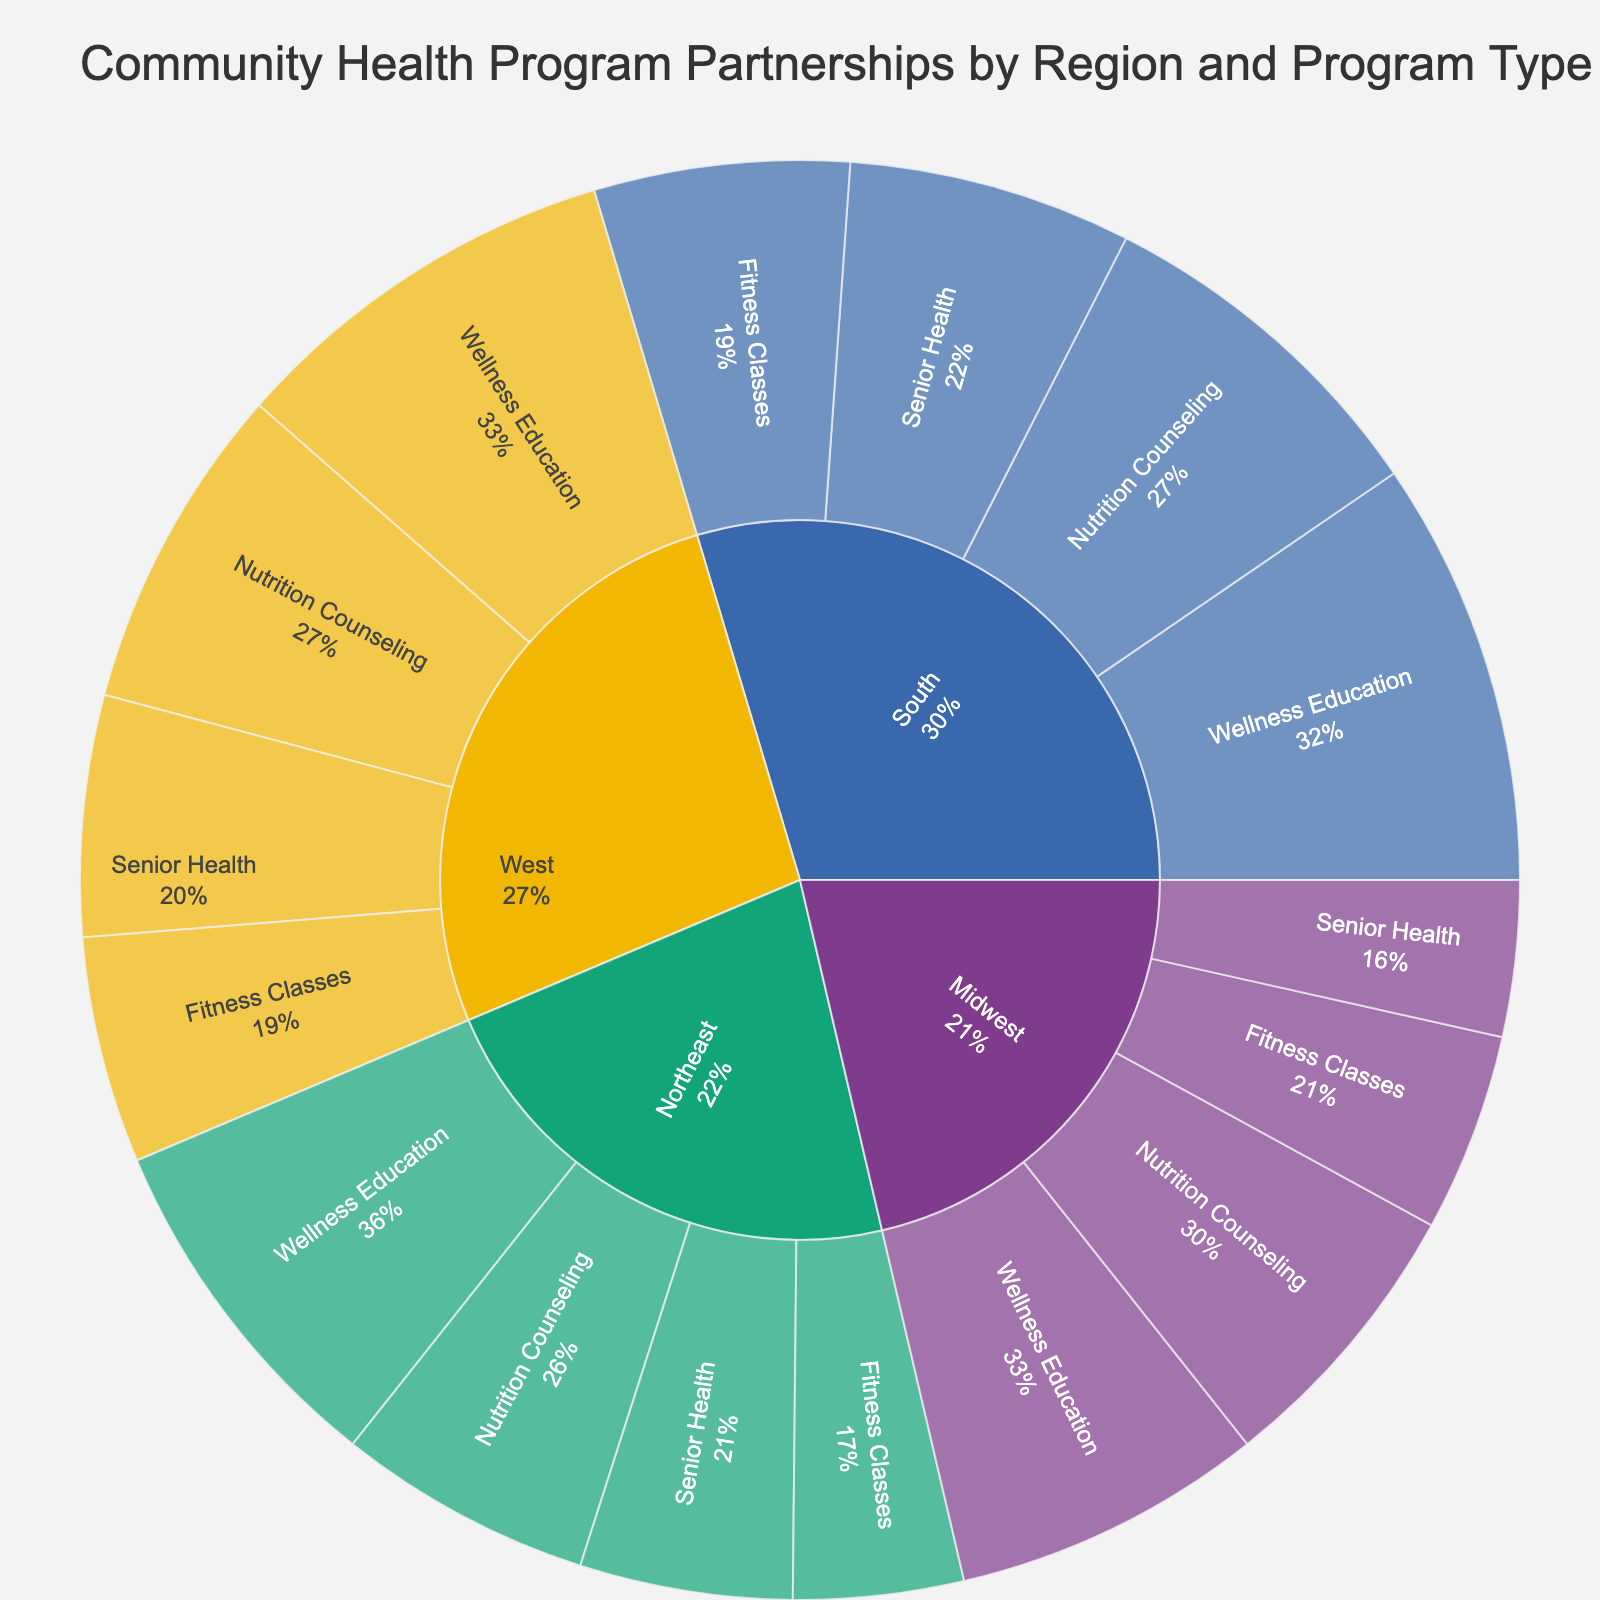what is the total number of partnerships in the Northeast region? Look for the section representing the Northeast region and sum up the partnerships for each program type: 25 (Wellness Education) + 18 (Nutrition Counseling) + 12 (Fitness Classes) + 15 (Senior Health) = 70
Answer: 70 What's the title of the figure? The title is usually displayed at the top of the figure.
Answer: Community Health Program Partnerships by Region and Program Type Which region has the highest number of partnerships in Wellness Education? Compare the Wellness Education partnerships across all regions: Northeast (25), Midwest (22), South (30), West (28). The South region has the highest number with 30 partnerships.
Answer: South Between the Midwest and the West, which region has more total partnerships? Sum the partnerships for each region: Midwest: 22 (Wellness Education) + 20 (Nutrition Counseling) + 14 (Fitness Classes) + 11 (Senior Health) = 67; West: 28 (Wellness Education) + 23 (Nutrition Counseling) + 16 (Fitness Classes) + 17 (Senior Health) = 84. The West has more total partnerships.
Answer: West What percentage of partnerships in the Northeast are for Fitness Classes? Calculate the total partnerships in the Northeast (70) and the number for Fitness Classes (12), then find the percentage: (12/70) * 100 = 17.14%
Answer: 17.14% Which program type has the least number of partnerships in the Midwest? Compare the partnerships for each program type within the Midwest: Wellness Education (22), Nutrition Counseling (20), Fitness Classes (14), Senior Health (11). Senior Health has the least with 11 partnerships.
Answer: Senior Health How many more partnerships does the South region have in Nutrition Counseling compared to the Midwest? Compare the partnerships in Nutrition Counseling for each region: South (25) - Midwest (20) = 5. The South has 5 more partnerships than the Midwest.
Answer: 5 What is the combined percentage share of Nutrition Counseling and Fitness Classes in the West region of their subregion? Calculate the total partnerships for the West (84). For Nutrition Counseling: (23/84) * 100 ≈ 27.38%. For Fitness Classes: (16/84) * 100 ≈ 19.05%. Combined percentage: 27.38% + 19.05% ≈ 46.43%.
Answer: 46.43% In which region does Senior Health have the highest percentage of partnerships relative to its subregion? Calculate the percentage of partnerships for Senior Health in each region's subregion. Compare: 
Northeast: (15/70) * 100 ≈ 21.43%
Midwest: (11/67) * 100 ≈ 16.42%
South: (20/93) * 100 ≈ 21.51%
West: (17/84) * 100 ≈ 20.24%
The South has the highest percentage at approximately 21.51%.
Answer: South 